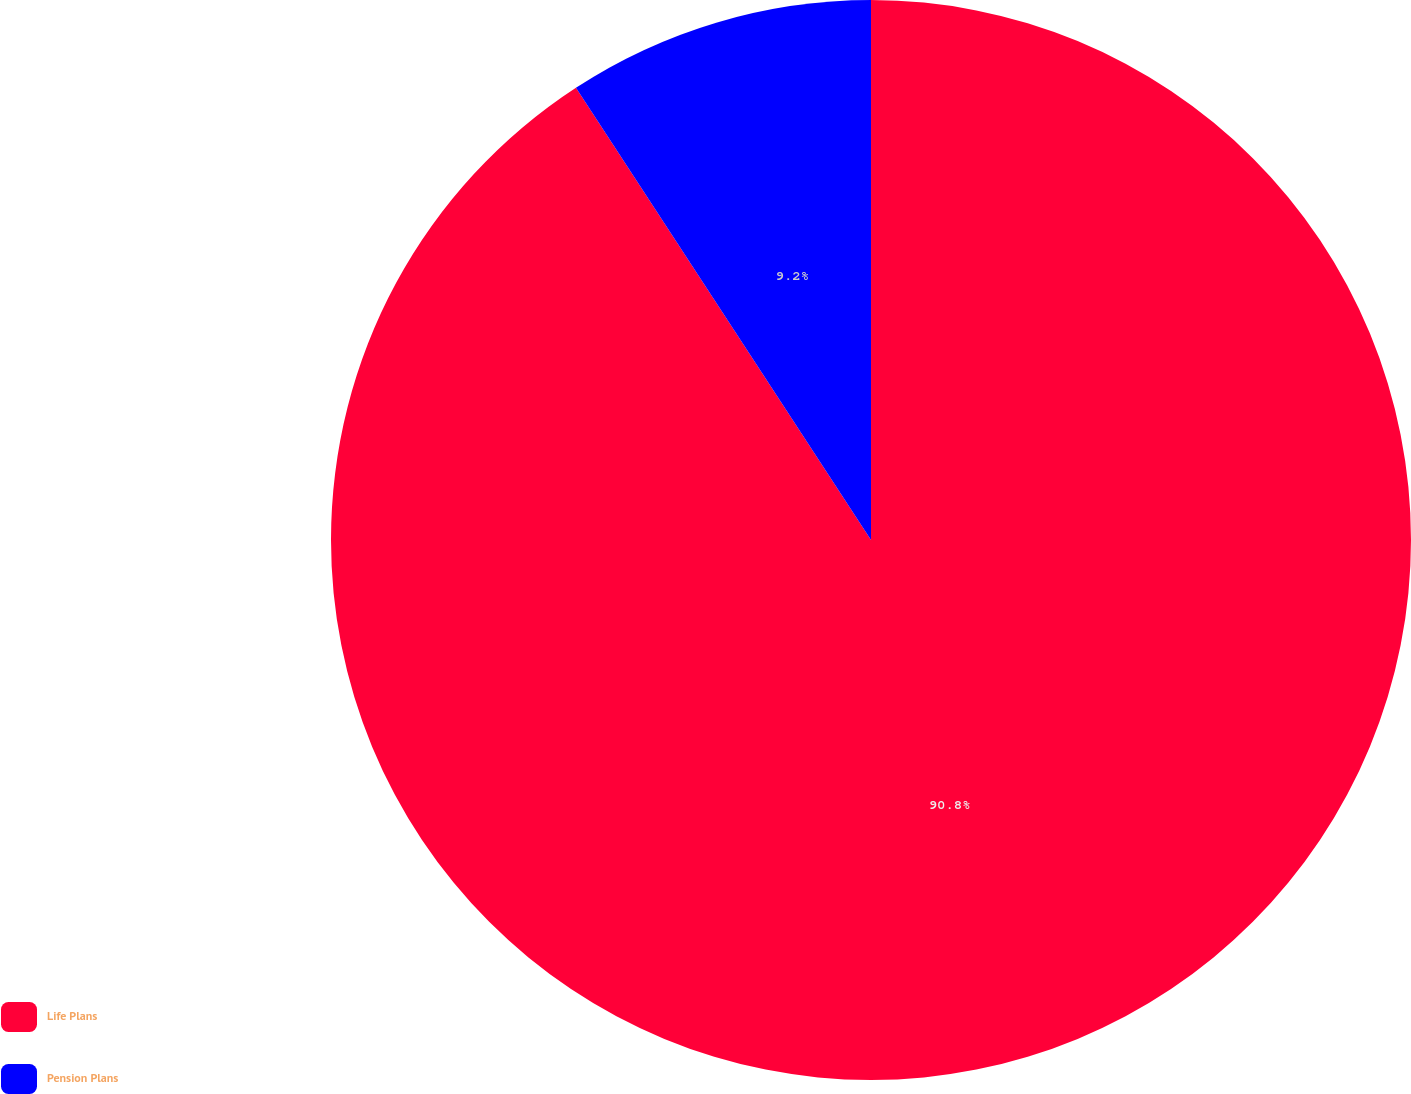Convert chart. <chart><loc_0><loc_0><loc_500><loc_500><pie_chart><fcel>Life Plans<fcel>Pension Plans<nl><fcel>90.8%<fcel>9.2%<nl></chart> 